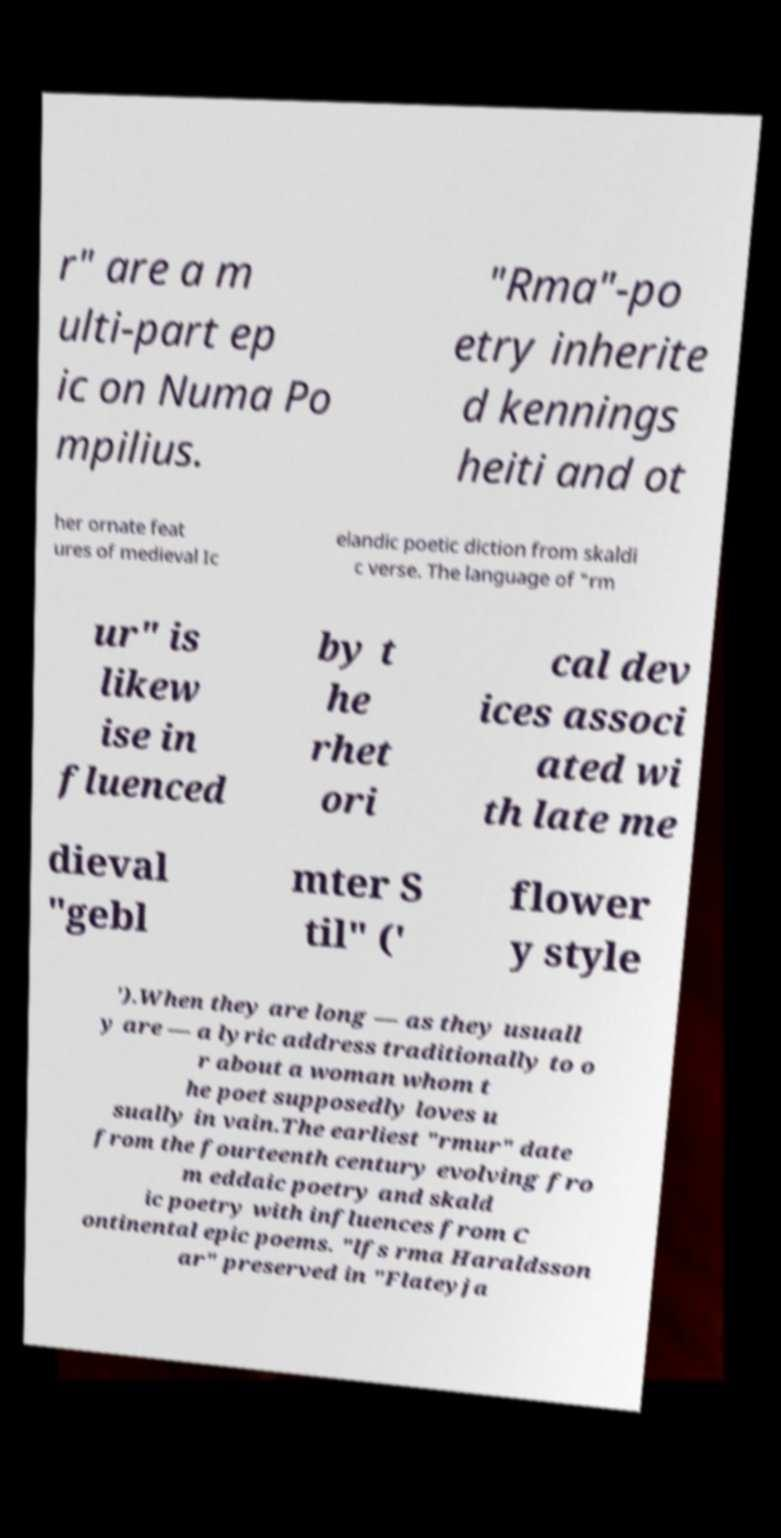For documentation purposes, I need the text within this image transcribed. Could you provide that? r" are a m ulti-part ep ic on Numa Po mpilius. "Rma"-po etry inherite d kennings heiti and ot her ornate feat ures of medieval Ic elandic poetic diction from skaldi c verse. The language of "rm ur" is likew ise in fluenced by t he rhet ori cal dev ices associ ated wi th late me dieval "gebl mter S til" (' flower y style ').When they are long — as they usuall y are — a lyric address traditionally to o r about a woman whom t he poet supposedly loves u sually in vain.The earliest "rmur" date from the fourteenth century evolving fro m eddaic poetry and skald ic poetry with influences from C ontinental epic poems. "lfs rma Haraldsson ar" preserved in "Flateyja 